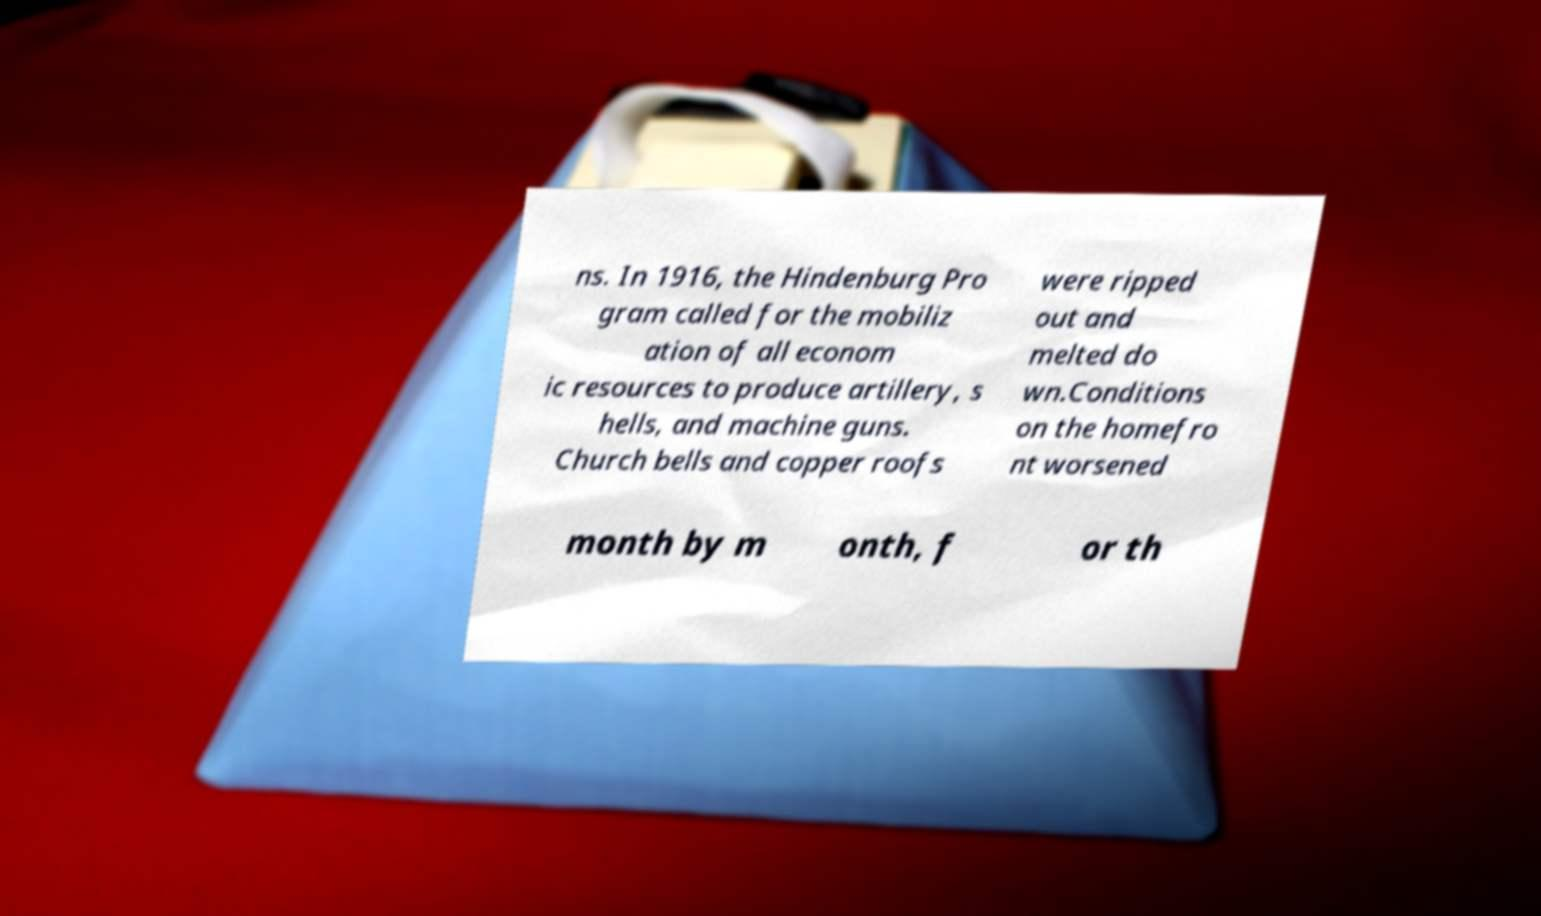There's text embedded in this image that I need extracted. Can you transcribe it verbatim? ns. In 1916, the Hindenburg Pro gram called for the mobiliz ation of all econom ic resources to produce artillery, s hells, and machine guns. Church bells and copper roofs were ripped out and melted do wn.Conditions on the homefro nt worsened month by m onth, f or th 